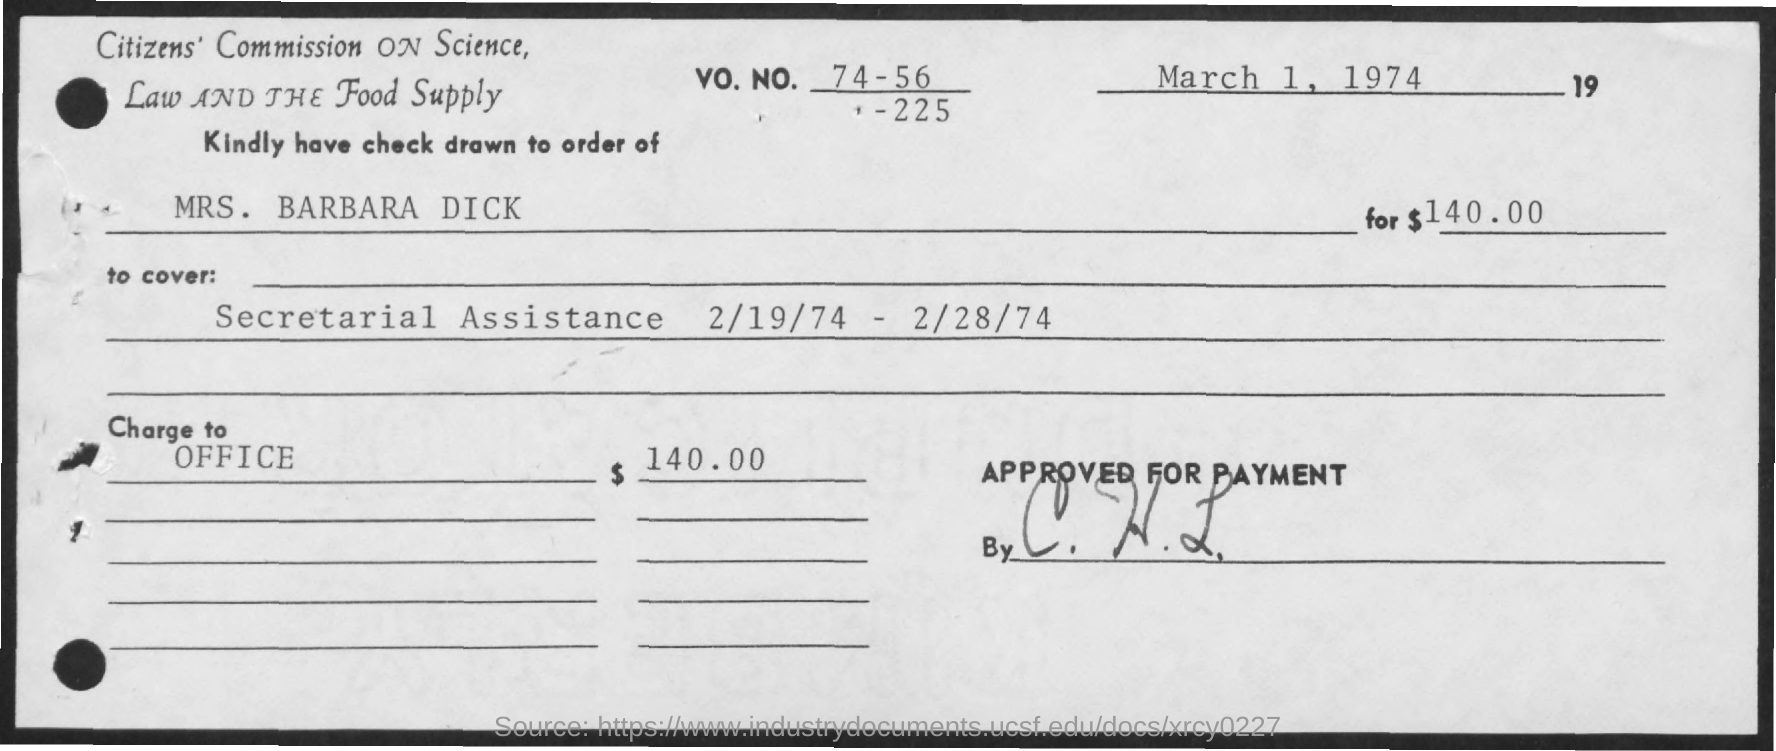List a handful of essential elements in this visual. The check is issued in the name of Mrs. Barbara Dick. The Vo. No. mentioned in the check is 74-56-225. The issued date of the check is March 1, 1974. The amount of the check issued is $140.00. 